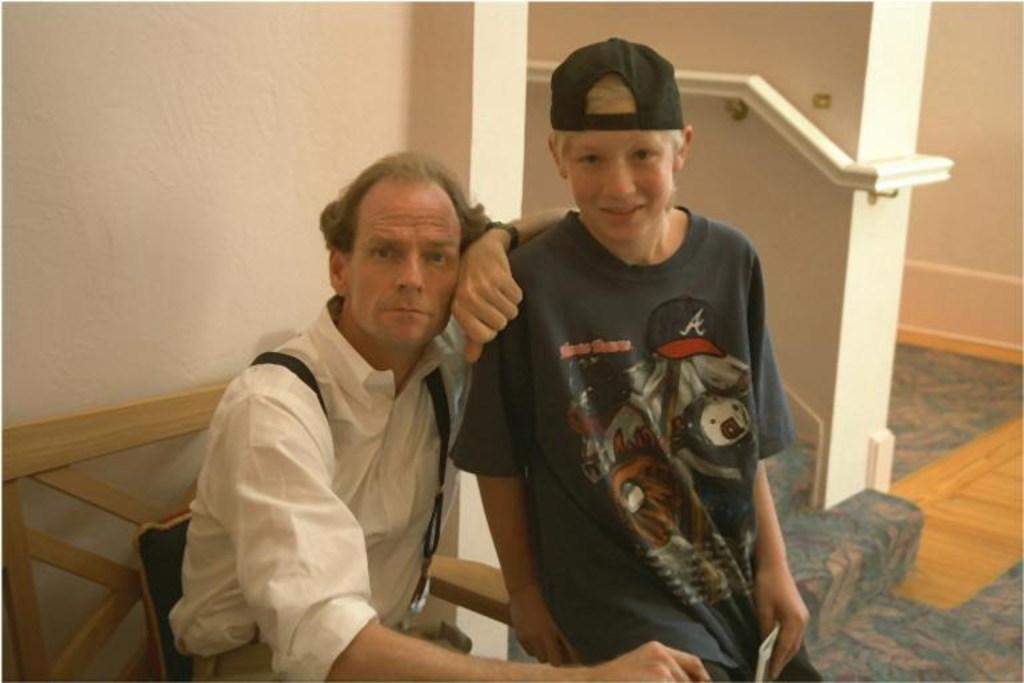How many people are in the image? There are two persons in the image. What is one person doing in the image? One person is sitting in a chair. What architectural feature is present in the image? There are stairs in the middle of the image. What type of headwear is one person wearing? One of the persons is wearing a cap. Can you tell me how many chickens are present in the image? There are no chickens present in the image. What type of station is visible in the image? There is no station visible in the image. 